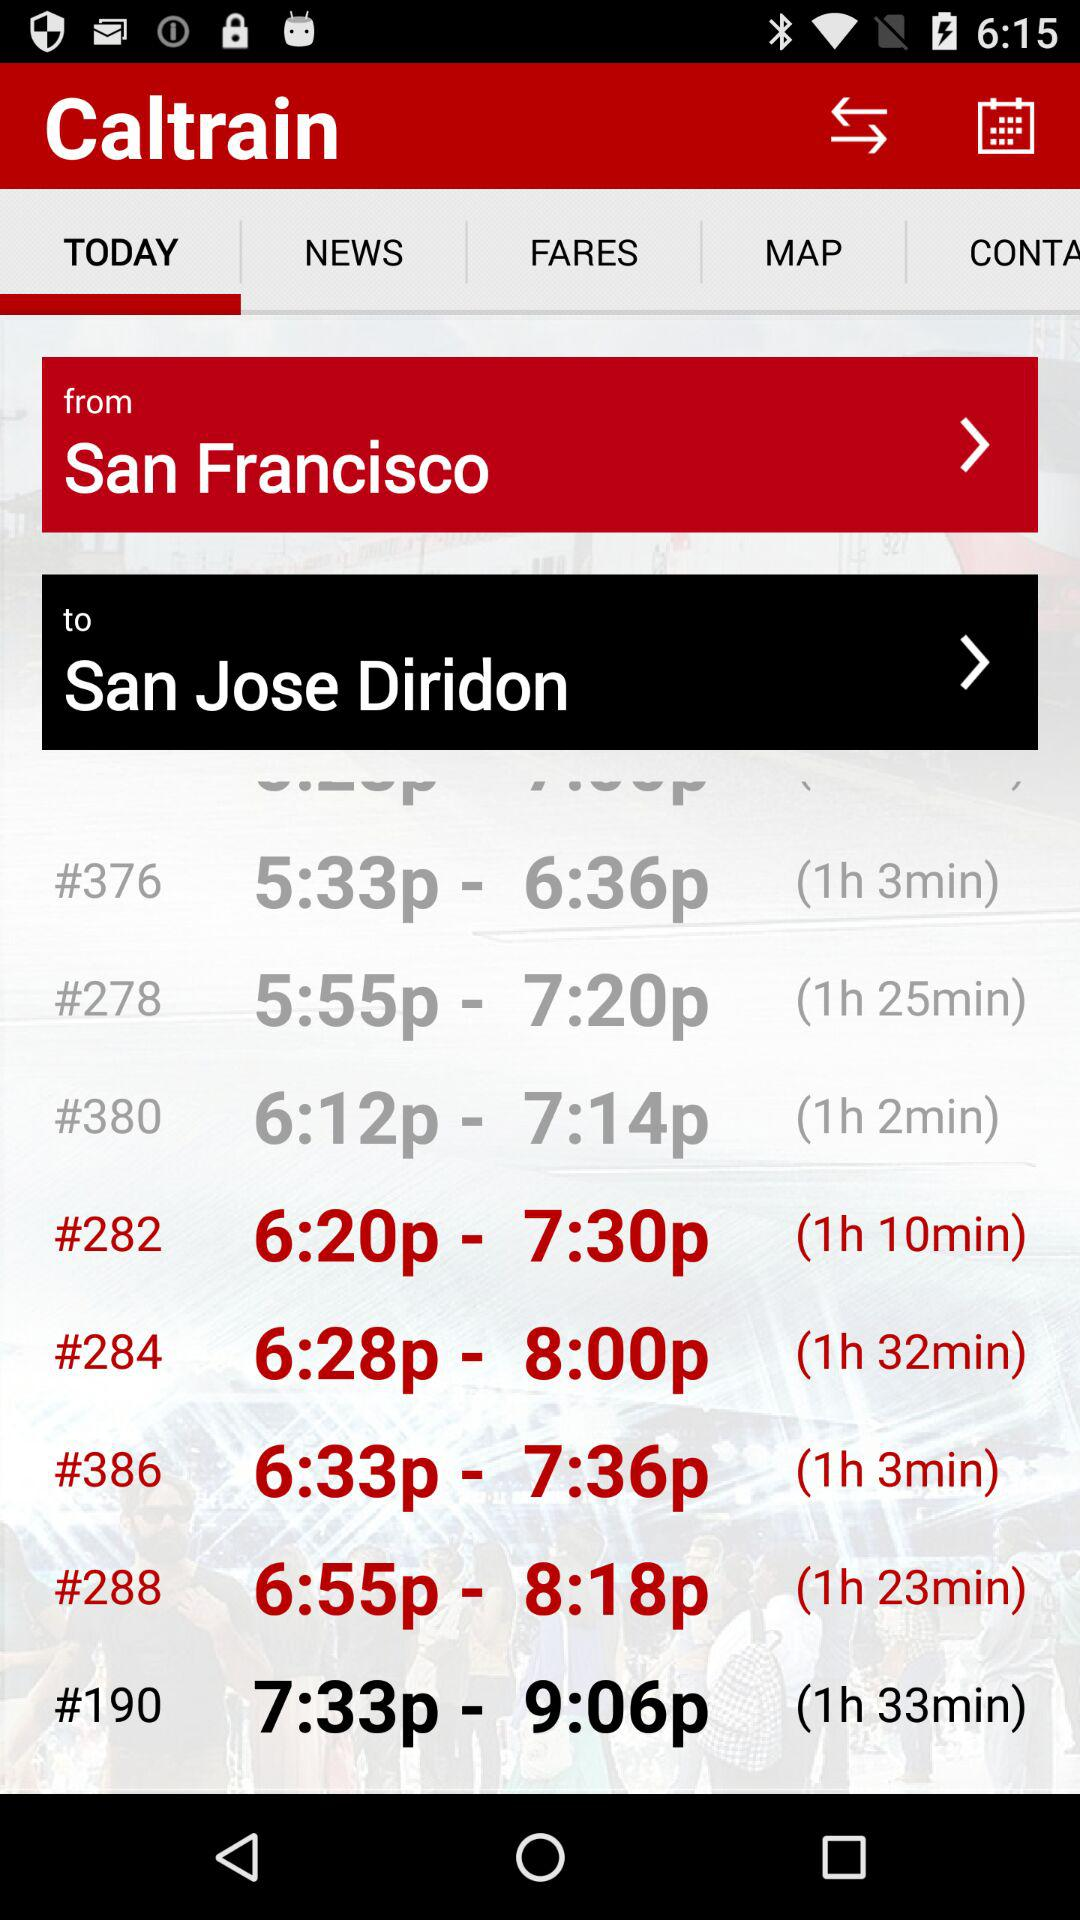Which route number takes 1 hour and 2 minutes? The route number is 380. 